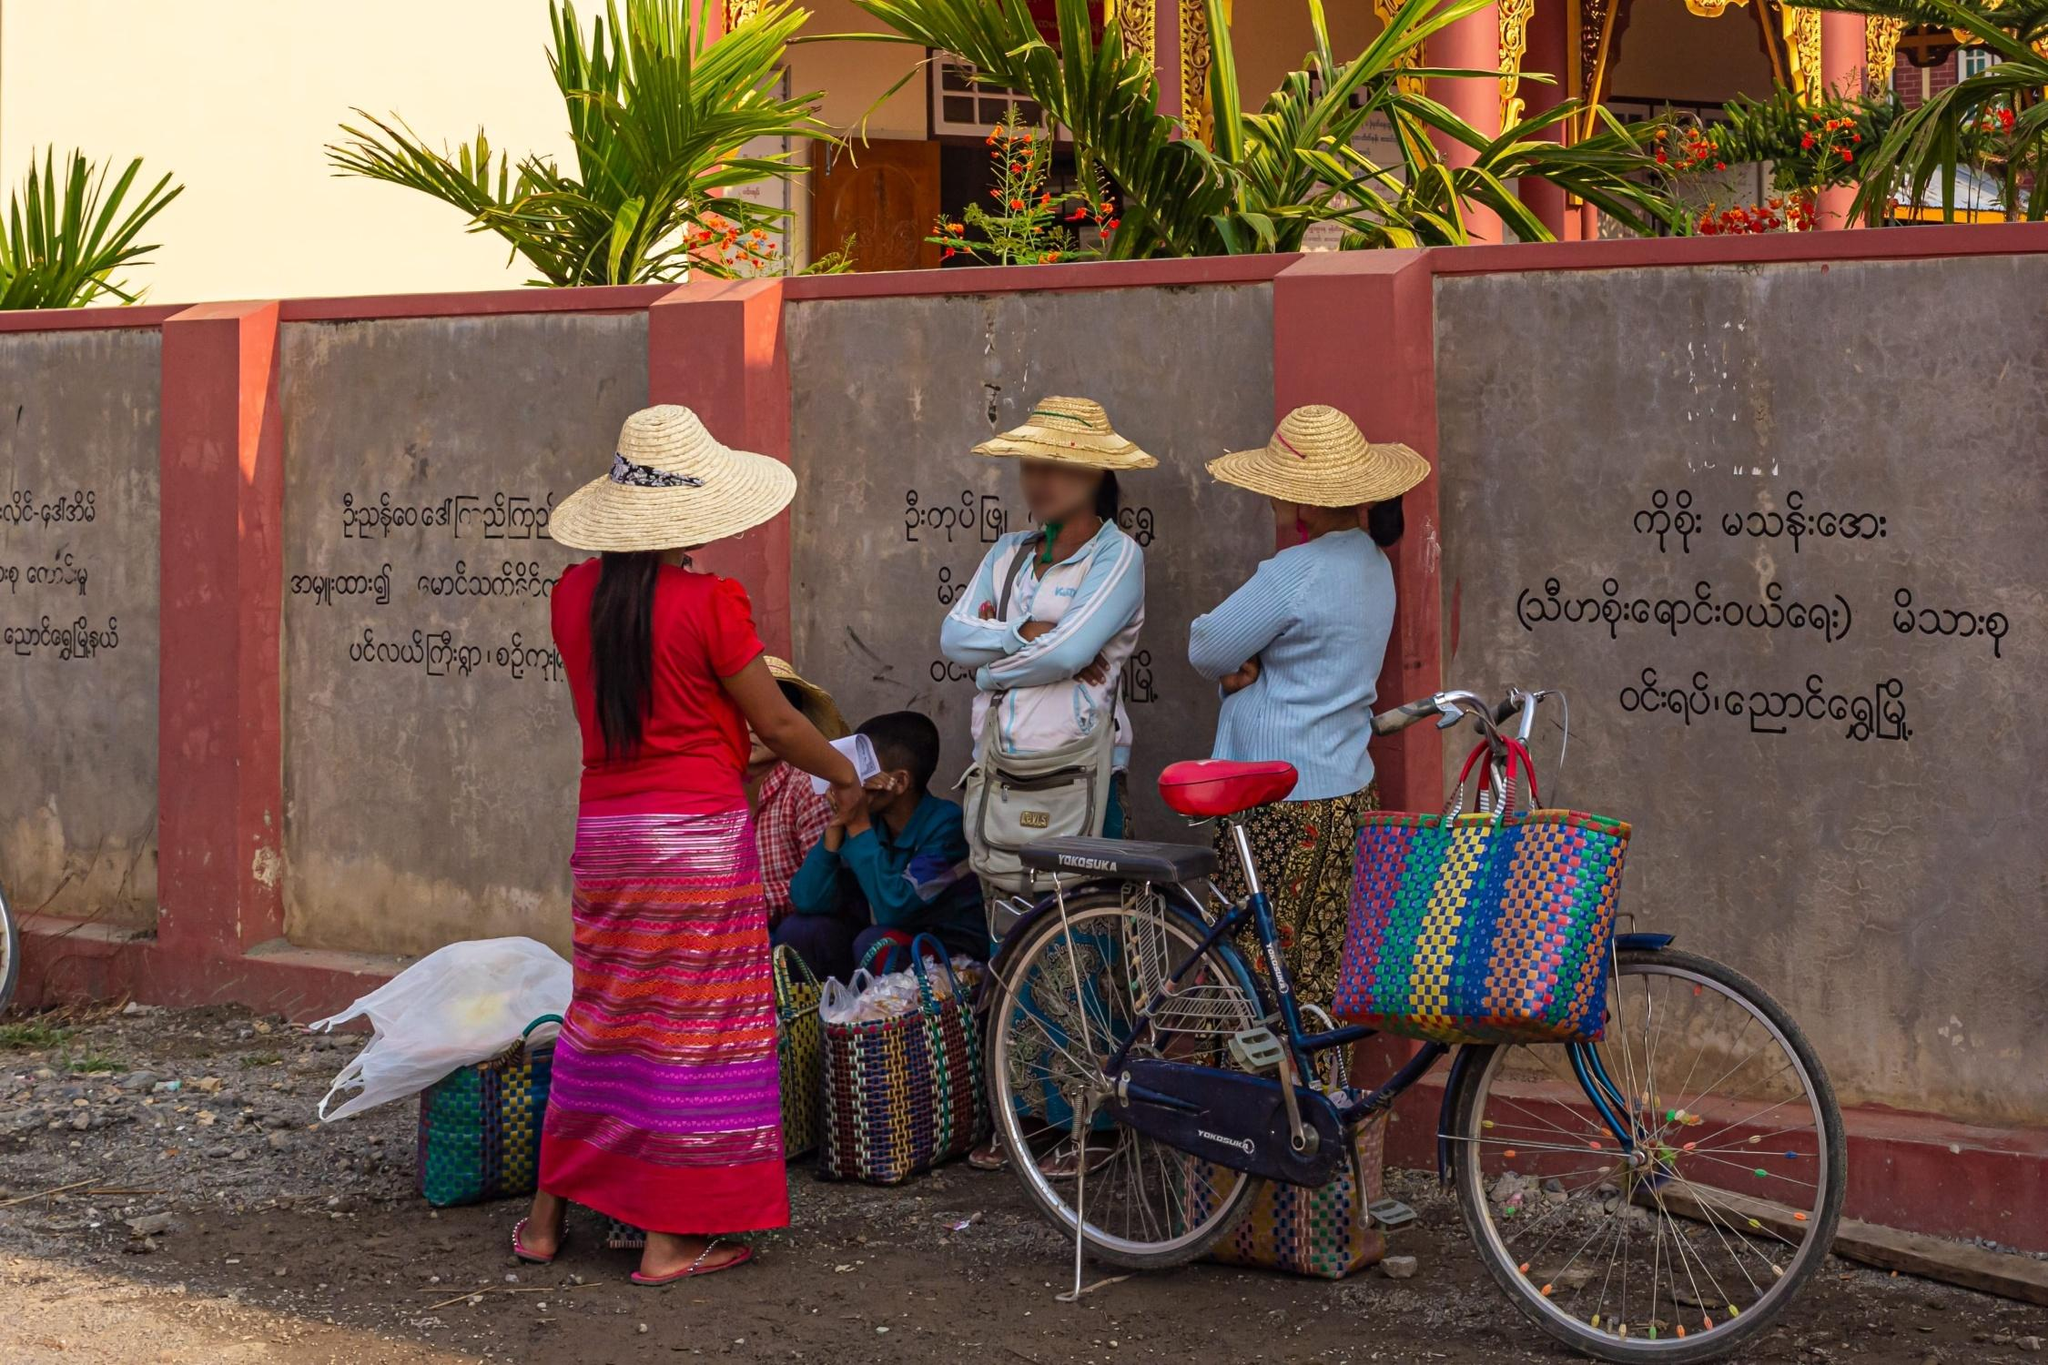What might the text on the wall indicate about this location? The text on the wall is written in Burmese script, which strongly hints that this scene is located in Myanmar. The presence of religious and cultural motifs in the script could suggest proximity to a temple or a culturally significant building. This type of script often includes moral precepts, announcements, or community-related information, which serves not only a decorative purpose but also a communicative function to those who pass by or gather in this spot. 